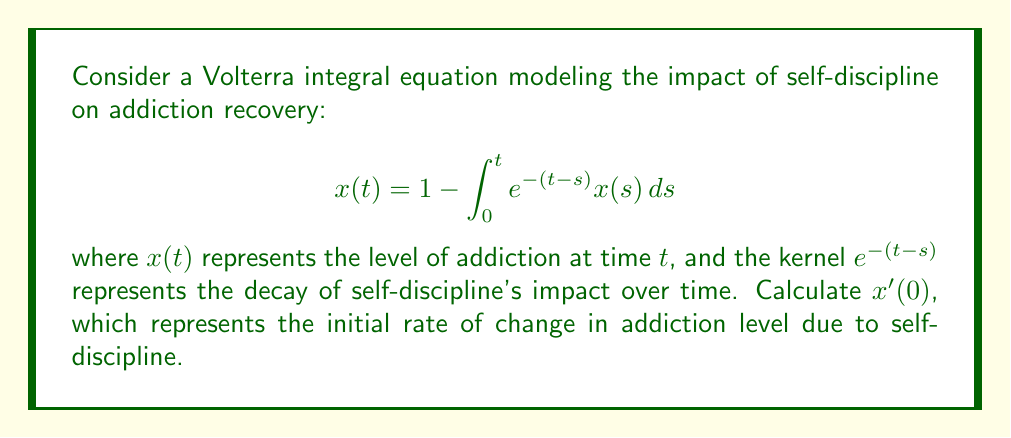Can you answer this question? To find $x'(0)$, we need to differentiate both sides of the equation with respect to $t$ and then evaluate at $t=0$:

1) Differentiate the left side:
   $$\frac{d}{dt}x(t) = x'(t)$$

2) Differentiate the right side using the Leibniz integral rule:
   $$\frac{d}{dt}\left(1 - \int_0^t e^{-(t-s)} x(s) ds\right) = -e^{-(t-t)}x(t) + \int_0^t \frac{\partial}{\partial t}(e^{-(t-s)})x(s)ds$$

3) Simplify:
   $$x'(t) = -x(t) - \int_0^t (-e^{-(t-s)})x(s)ds$$

4) Rearrange:
   $$x'(t) = -x(t) + \int_0^t e^{-(t-s)}x(s)ds$$

5) Substitute the original equation for the integral term:
   $$x'(t) = -x(t) + (1 - x(t)) = 1 - 2x(t)$$

6) Evaluate at $t=0$:
   $$x'(0) = 1 - 2x(0)$$

7) From the original equation, we can see that $x(0) = 1$:
   $$x'(0) = 1 - 2(1) = -1$$

Therefore, $x'(0) = -1$.
Answer: $-1$ 